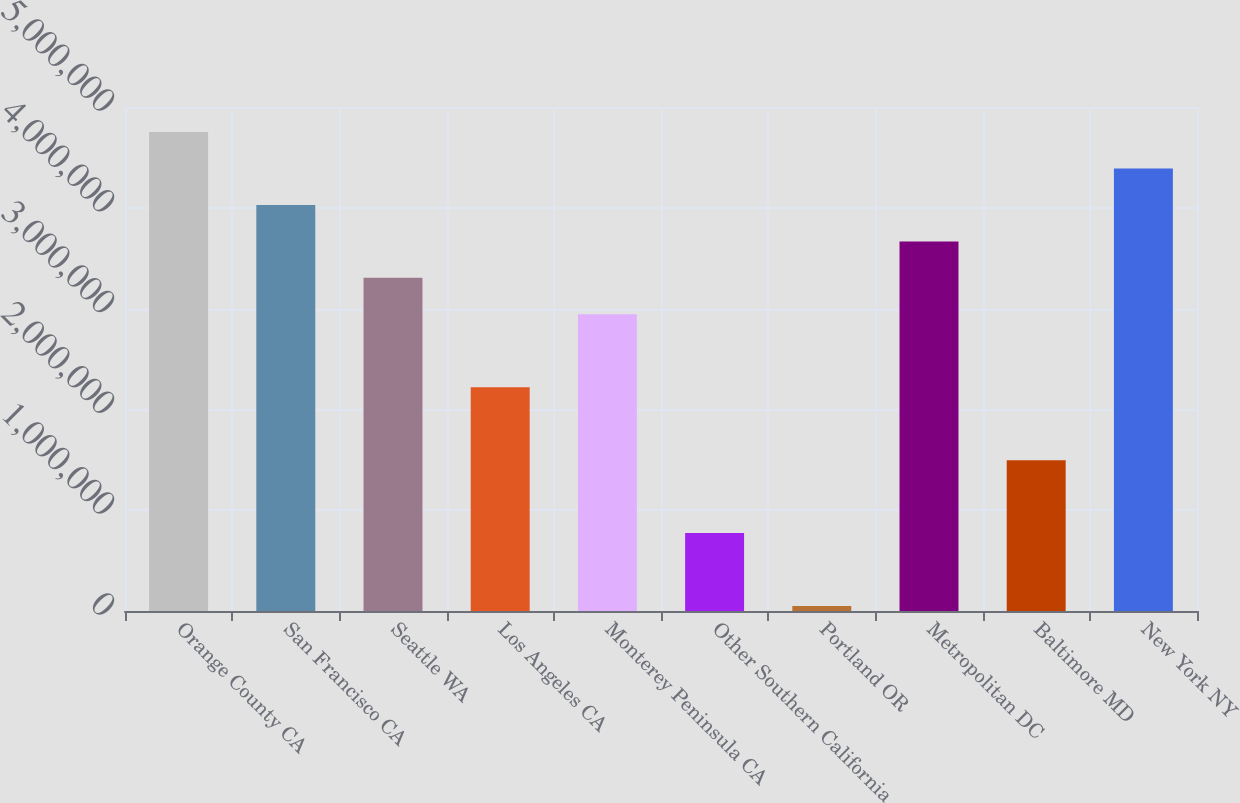Convert chart. <chart><loc_0><loc_0><loc_500><loc_500><bar_chart><fcel>Orange County CA<fcel>San Francisco CA<fcel>Seattle WA<fcel>Los Angeles CA<fcel>Monterey Peninsula CA<fcel>Other Southern California<fcel>Portland OR<fcel>Metropolitan DC<fcel>Baltimore MD<fcel>New York NY<nl><fcel>4.75206e+06<fcel>4.02853e+06<fcel>3.305e+06<fcel>2.2197e+06<fcel>2.94323e+06<fcel>772643<fcel>49113<fcel>3.66676e+06<fcel>1.49617e+06<fcel>4.3903e+06<nl></chart> 